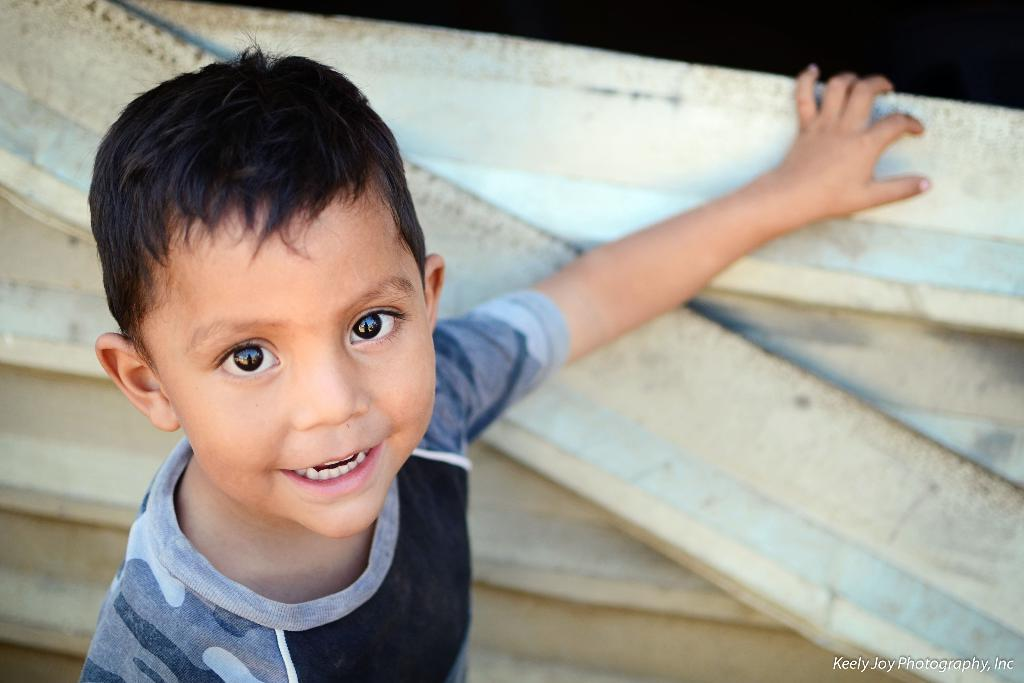Who is the main subject in the image? There is a boy in the image. What is the boy doing in the image? The boy is standing in the image. What is the boy's facial expression in the image? The boy is smiling in the image. What is the boy wearing in the image? The boy is wearing a grey and black t-shirt in the image. What type of servant is standing next to the boy in the image? There is no servant present in the image; it only features the boy. How many leaves are visible on the ground in the image? There are no leaves visible in the image; it is focused solely on the boy. 